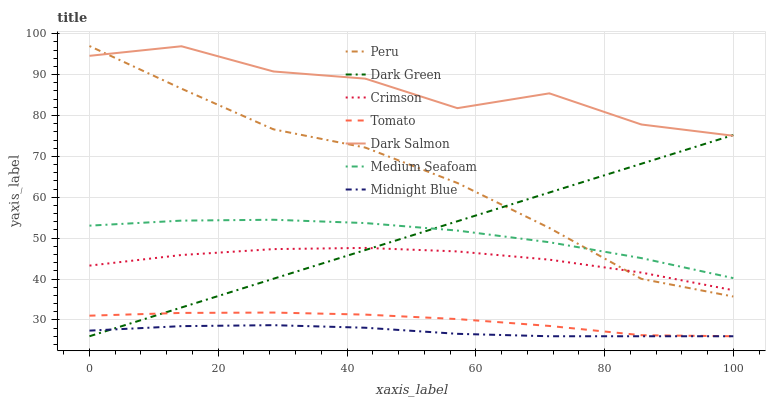Does Dark Salmon have the minimum area under the curve?
Answer yes or no. No. Does Midnight Blue have the maximum area under the curve?
Answer yes or no. No. Is Midnight Blue the smoothest?
Answer yes or no. No. Is Midnight Blue the roughest?
Answer yes or no. No. Does Dark Salmon have the lowest value?
Answer yes or no. No. Does Dark Salmon have the highest value?
Answer yes or no. No. Is Tomato less than Dark Salmon?
Answer yes or no. Yes. Is Crimson greater than Tomato?
Answer yes or no. Yes. Does Tomato intersect Dark Salmon?
Answer yes or no. No. 